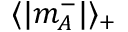<formula> <loc_0><loc_0><loc_500><loc_500>\langle | m _ { A } ^ { - } | \rangle _ { + }</formula> 